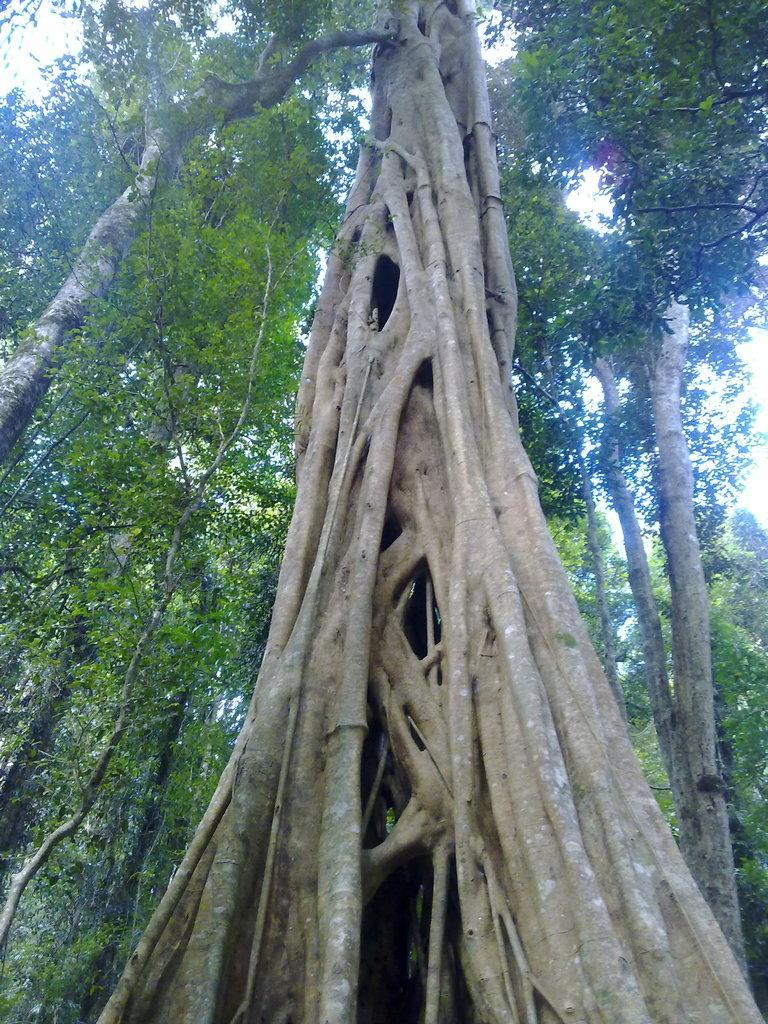How would you summarize this image in a sentence or two? In this image we can see a tree trunk. In the background there are trees. Also there is sky. 